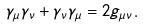<formula> <loc_0><loc_0><loc_500><loc_500>\gamma _ { \mu } \gamma _ { \nu } + \gamma _ { \nu } \gamma _ { \mu } = 2 g _ { \mu \nu } .</formula> 